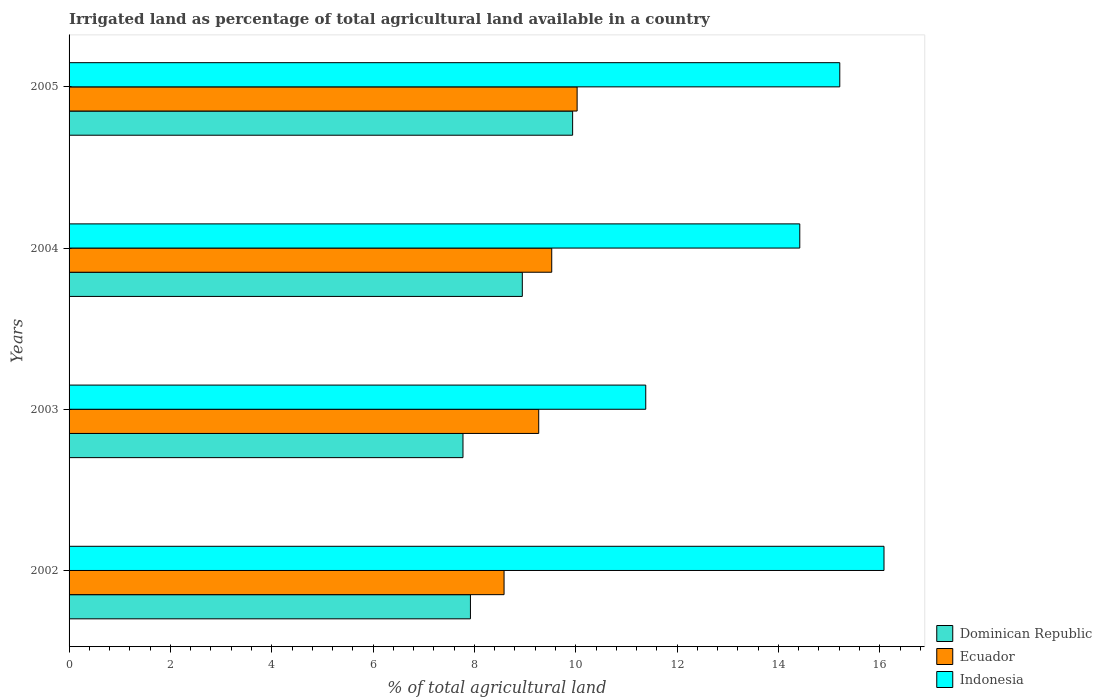How many different coloured bars are there?
Your response must be concise. 3. Are the number of bars per tick equal to the number of legend labels?
Offer a terse response. Yes. How many bars are there on the 3rd tick from the top?
Provide a short and direct response. 3. What is the percentage of irrigated land in Ecuador in 2003?
Provide a short and direct response. 9.27. Across all years, what is the maximum percentage of irrigated land in Ecuador?
Provide a short and direct response. 10.03. Across all years, what is the minimum percentage of irrigated land in Ecuador?
Provide a succinct answer. 8.58. In which year was the percentage of irrigated land in Indonesia maximum?
Your answer should be very brief. 2002. In which year was the percentage of irrigated land in Dominican Republic minimum?
Ensure brevity in your answer.  2003. What is the total percentage of irrigated land in Indonesia in the graph?
Offer a terse response. 57.1. What is the difference between the percentage of irrigated land in Dominican Republic in 2002 and that in 2004?
Make the answer very short. -1.02. What is the difference between the percentage of irrigated land in Ecuador in 2005 and the percentage of irrigated land in Indonesia in 2002?
Offer a terse response. -6.06. What is the average percentage of irrigated land in Dominican Republic per year?
Your answer should be very brief. 8.64. In the year 2004, what is the difference between the percentage of irrigated land in Indonesia and percentage of irrigated land in Ecuador?
Offer a terse response. 4.9. In how many years, is the percentage of irrigated land in Ecuador greater than 2.4 %?
Your response must be concise. 4. What is the ratio of the percentage of irrigated land in Indonesia in 2003 to that in 2004?
Ensure brevity in your answer.  0.79. Is the difference between the percentage of irrigated land in Indonesia in 2002 and 2005 greater than the difference between the percentage of irrigated land in Ecuador in 2002 and 2005?
Offer a terse response. Yes. What is the difference between the highest and the second highest percentage of irrigated land in Ecuador?
Your answer should be compact. 0.5. What is the difference between the highest and the lowest percentage of irrigated land in Ecuador?
Provide a succinct answer. 1.44. Is the sum of the percentage of irrigated land in Ecuador in 2003 and 2005 greater than the maximum percentage of irrigated land in Indonesia across all years?
Your response must be concise. Yes. What does the 1st bar from the bottom in 2004 represents?
Provide a succinct answer. Dominican Republic. How many bars are there?
Make the answer very short. 12. How many years are there in the graph?
Your answer should be compact. 4. What is the difference between two consecutive major ticks on the X-axis?
Make the answer very short. 2. Are the values on the major ticks of X-axis written in scientific E-notation?
Your answer should be very brief. No. Does the graph contain any zero values?
Make the answer very short. No. Does the graph contain grids?
Provide a succinct answer. No. Where does the legend appear in the graph?
Ensure brevity in your answer.  Bottom right. How many legend labels are there?
Keep it short and to the point. 3. How are the legend labels stacked?
Ensure brevity in your answer.  Vertical. What is the title of the graph?
Your answer should be very brief. Irrigated land as percentage of total agricultural land available in a country. Does "Sweden" appear as one of the legend labels in the graph?
Ensure brevity in your answer.  No. What is the label or title of the X-axis?
Offer a terse response. % of total agricultural land. What is the % of total agricultural land of Dominican Republic in 2002?
Provide a short and direct response. 7.92. What is the % of total agricultural land in Ecuador in 2002?
Ensure brevity in your answer.  8.58. What is the % of total agricultural land in Indonesia in 2002?
Provide a short and direct response. 16.08. What is the % of total agricultural land of Dominican Republic in 2003?
Your response must be concise. 7.77. What is the % of total agricultural land of Ecuador in 2003?
Provide a succinct answer. 9.27. What is the % of total agricultural land in Indonesia in 2003?
Your answer should be very brief. 11.38. What is the % of total agricultural land of Dominican Republic in 2004?
Your response must be concise. 8.94. What is the % of total agricultural land of Ecuador in 2004?
Keep it short and to the point. 9.53. What is the % of total agricultural land of Indonesia in 2004?
Keep it short and to the point. 14.42. What is the % of total agricultural land of Dominican Republic in 2005?
Ensure brevity in your answer.  9.94. What is the % of total agricultural land in Ecuador in 2005?
Ensure brevity in your answer.  10.03. What is the % of total agricultural land in Indonesia in 2005?
Provide a succinct answer. 15.21. Across all years, what is the maximum % of total agricultural land of Dominican Republic?
Your answer should be compact. 9.94. Across all years, what is the maximum % of total agricultural land in Ecuador?
Give a very brief answer. 10.03. Across all years, what is the maximum % of total agricultural land in Indonesia?
Offer a terse response. 16.08. Across all years, what is the minimum % of total agricultural land in Dominican Republic?
Offer a terse response. 7.77. Across all years, what is the minimum % of total agricultural land in Ecuador?
Your response must be concise. 8.58. Across all years, what is the minimum % of total agricultural land of Indonesia?
Ensure brevity in your answer.  11.38. What is the total % of total agricultural land in Dominican Republic in the graph?
Offer a very short reply. 34.58. What is the total % of total agricultural land of Ecuador in the graph?
Your answer should be compact. 37.41. What is the total % of total agricultural land in Indonesia in the graph?
Provide a short and direct response. 57.1. What is the difference between the % of total agricultural land in Dominican Republic in 2002 and that in 2003?
Your response must be concise. 0.15. What is the difference between the % of total agricultural land of Ecuador in 2002 and that in 2003?
Your answer should be very brief. -0.68. What is the difference between the % of total agricultural land in Indonesia in 2002 and that in 2003?
Your answer should be very brief. 4.7. What is the difference between the % of total agricultural land in Dominican Republic in 2002 and that in 2004?
Your answer should be compact. -1.02. What is the difference between the % of total agricultural land in Ecuador in 2002 and that in 2004?
Provide a short and direct response. -0.94. What is the difference between the % of total agricultural land of Indonesia in 2002 and that in 2004?
Offer a very short reply. 1.66. What is the difference between the % of total agricultural land in Dominican Republic in 2002 and that in 2005?
Provide a succinct answer. -2.02. What is the difference between the % of total agricultural land of Ecuador in 2002 and that in 2005?
Offer a terse response. -1.44. What is the difference between the % of total agricultural land of Indonesia in 2002 and that in 2005?
Offer a very short reply. 0.87. What is the difference between the % of total agricultural land of Dominican Republic in 2003 and that in 2004?
Offer a very short reply. -1.17. What is the difference between the % of total agricultural land in Ecuador in 2003 and that in 2004?
Your answer should be compact. -0.26. What is the difference between the % of total agricultural land of Indonesia in 2003 and that in 2004?
Give a very brief answer. -3.04. What is the difference between the % of total agricultural land of Dominican Republic in 2003 and that in 2005?
Ensure brevity in your answer.  -2.16. What is the difference between the % of total agricultural land of Ecuador in 2003 and that in 2005?
Your answer should be compact. -0.76. What is the difference between the % of total agricultural land in Indonesia in 2003 and that in 2005?
Make the answer very short. -3.83. What is the difference between the % of total agricultural land of Dominican Republic in 2004 and that in 2005?
Ensure brevity in your answer.  -0.99. What is the difference between the % of total agricultural land in Ecuador in 2004 and that in 2005?
Keep it short and to the point. -0.5. What is the difference between the % of total agricultural land in Indonesia in 2004 and that in 2005?
Provide a short and direct response. -0.79. What is the difference between the % of total agricultural land of Dominican Republic in 2002 and the % of total agricultural land of Ecuador in 2003?
Your answer should be compact. -1.35. What is the difference between the % of total agricultural land in Dominican Republic in 2002 and the % of total agricultural land in Indonesia in 2003?
Make the answer very short. -3.46. What is the difference between the % of total agricultural land in Ecuador in 2002 and the % of total agricultural land in Indonesia in 2003?
Give a very brief answer. -2.8. What is the difference between the % of total agricultural land of Dominican Republic in 2002 and the % of total agricultural land of Ecuador in 2004?
Offer a terse response. -1.6. What is the difference between the % of total agricultural land in Dominican Republic in 2002 and the % of total agricultural land in Indonesia in 2004?
Your response must be concise. -6.5. What is the difference between the % of total agricultural land in Ecuador in 2002 and the % of total agricultural land in Indonesia in 2004?
Give a very brief answer. -5.84. What is the difference between the % of total agricultural land in Dominican Republic in 2002 and the % of total agricultural land in Ecuador in 2005?
Ensure brevity in your answer.  -2.11. What is the difference between the % of total agricultural land in Dominican Republic in 2002 and the % of total agricultural land in Indonesia in 2005?
Make the answer very short. -7.29. What is the difference between the % of total agricultural land of Ecuador in 2002 and the % of total agricultural land of Indonesia in 2005?
Offer a terse response. -6.63. What is the difference between the % of total agricultural land in Dominican Republic in 2003 and the % of total agricultural land in Ecuador in 2004?
Keep it short and to the point. -1.75. What is the difference between the % of total agricultural land of Dominican Republic in 2003 and the % of total agricultural land of Indonesia in 2004?
Provide a short and direct response. -6.65. What is the difference between the % of total agricultural land in Ecuador in 2003 and the % of total agricultural land in Indonesia in 2004?
Your response must be concise. -5.15. What is the difference between the % of total agricultural land of Dominican Republic in 2003 and the % of total agricultural land of Ecuador in 2005?
Provide a short and direct response. -2.25. What is the difference between the % of total agricultural land in Dominican Republic in 2003 and the % of total agricultural land in Indonesia in 2005?
Make the answer very short. -7.44. What is the difference between the % of total agricultural land in Ecuador in 2003 and the % of total agricultural land in Indonesia in 2005?
Provide a short and direct response. -5.94. What is the difference between the % of total agricultural land in Dominican Republic in 2004 and the % of total agricultural land in Ecuador in 2005?
Offer a very short reply. -1.08. What is the difference between the % of total agricultural land of Dominican Republic in 2004 and the % of total agricultural land of Indonesia in 2005?
Your response must be concise. -6.27. What is the difference between the % of total agricultural land of Ecuador in 2004 and the % of total agricultural land of Indonesia in 2005?
Provide a short and direct response. -5.68. What is the average % of total agricultural land of Dominican Republic per year?
Keep it short and to the point. 8.64. What is the average % of total agricultural land of Ecuador per year?
Keep it short and to the point. 9.35. What is the average % of total agricultural land of Indonesia per year?
Your answer should be compact. 14.27. In the year 2002, what is the difference between the % of total agricultural land of Dominican Republic and % of total agricultural land of Ecuador?
Your answer should be compact. -0.66. In the year 2002, what is the difference between the % of total agricultural land in Dominican Republic and % of total agricultural land in Indonesia?
Your response must be concise. -8.16. In the year 2002, what is the difference between the % of total agricultural land of Ecuador and % of total agricultural land of Indonesia?
Offer a very short reply. -7.5. In the year 2003, what is the difference between the % of total agricultural land of Dominican Republic and % of total agricultural land of Ecuador?
Your answer should be compact. -1.49. In the year 2003, what is the difference between the % of total agricultural land of Dominican Republic and % of total agricultural land of Indonesia?
Offer a very short reply. -3.61. In the year 2003, what is the difference between the % of total agricultural land in Ecuador and % of total agricultural land in Indonesia?
Keep it short and to the point. -2.11. In the year 2004, what is the difference between the % of total agricultural land in Dominican Republic and % of total agricultural land in Ecuador?
Your answer should be compact. -0.58. In the year 2004, what is the difference between the % of total agricultural land in Dominican Republic and % of total agricultural land in Indonesia?
Make the answer very short. -5.48. In the year 2004, what is the difference between the % of total agricultural land of Ecuador and % of total agricultural land of Indonesia?
Your answer should be very brief. -4.9. In the year 2005, what is the difference between the % of total agricultural land in Dominican Republic and % of total agricultural land in Ecuador?
Offer a very short reply. -0.09. In the year 2005, what is the difference between the % of total agricultural land in Dominican Republic and % of total agricultural land in Indonesia?
Make the answer very short. -5.27. In the year 2005, what is the difference between the % of total agricultural land of Ecuador and % of total agricultural land of Indonesia?
Give a very brief answer. -5.18. What is the ratio of the % of total agricultural land of Dominican Republic in 2002 to that in 2003?
Offer a terse response. 1.02. What is the ratio of the % of total agricultural land in Ecuador in 2002 to that in 2003?
Make the answer very short. 0.93. What is the ratio of the % of total agricultural land in Indonesia in 2002 to that in 2003?
Ensure brevity in your answer.  1.41. What is the ratio of the % of total agricultural land in Dominican Republic in 2002 to that in 2004?
Provide a short and direct response. 0.89. What is the ratio of the % of total agricultural land in Ecuador in 2002 to that in 2004?
Offer a terse response. 0.9. What is the ratio of the % of total agricultural land in Indonesia in 2002 to that in 2004?
Ensure brevity in your answer.  1.12. What is the ratio of the % of total agricultural land in Dominican Republic in 2002 to that in 2005?
Ensure brevity in your answer.  0.8. What is the ratio of the % of total agricultural land of Ecuador in 2002 to that in 2005?
Offer a very short reply. 0.86. What is the ratio of the % of total agricultural land of Indonesia in 2002 to that in 2005?
Your answer should be very brief. 1.06. What is the ratio of the % of total agricultural land in Dominican Republic in 2003 to that in 2004?
Give a very brief answer. 0.87. What is the ratio of the % of total agricultural land in Ecuador in 2003 to that in 2004?
Your response must be concise. 0.97. What is the ratio of the % of total agricultural land of Indonesia in 2003 to that in 2004?
Your answer should be compact. 0.79. What is the ratio of the % of total agricultural land of Dominican Republic in 2003 to that in 2005?
Your answer should be compact. 0.78. What is the ratio of the % of total agricultural land in Ecuador in 2003 to that in 2005?
Your response must be concise. 0.92. What is the ratio of the % of total agricultural land in Indonesia in 2003 to that in 2005?
Offer a very short reply. 0.75. What is the ratio of the % of total agricultural land of Dominican Republic in 2004 to that in 2005?
Give a very brief answer. 0.9. What is the ratio of the % of total agricultural land of Indonesia in 2004 to that in 2005?
Make the answer very short. 0.95. What is the difference between the highest and the second highest % of total agricultural land of Ecuador?
Provide a succinct answer. 0.5. What is the difference between the highest and the second highest % of total agricultural land in Indonesia?
Your answer should be compact. 0.87. What is the difference between the highest and the lowest % of total agricultural land in Dominican Republic?
Your answer should be compact. 2.16. What is the difference between the highest and the lowest % of total agricultural land of Ecuador?
Keep it short and to the point. 1.44. What is the difference between the highest and the lowest % of total agricultural land in Indonesia?
Ensure brevity in your answer.  4.7. 